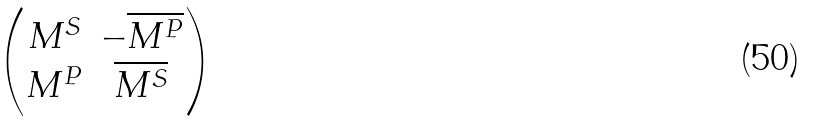<formula> <loc_0><loc_0><loc_500><loc_500>\begin{pmatrix} { M } ^ { S } & - \overline { { M } ^ { P } } \\ { M } ^ { P } & \overline { { M } ^ { S } } \end{pmatrix}</formula> 